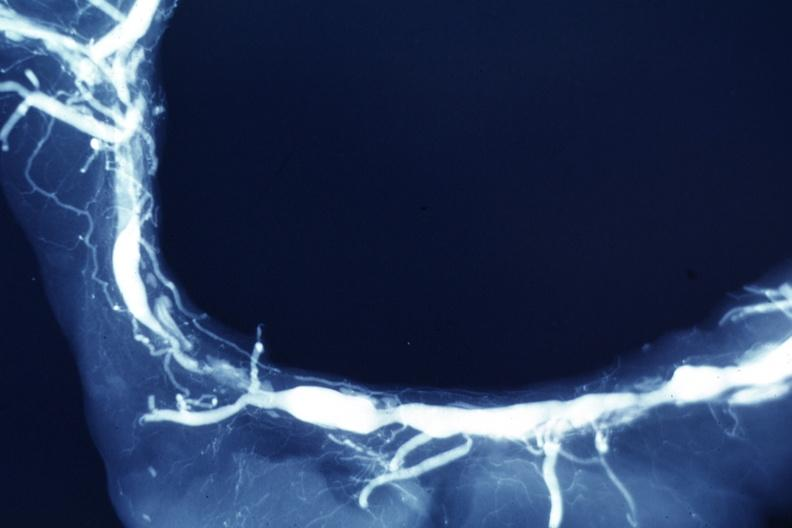s cardiovascular present?
Answer the question using a single word or phrase. Yes 